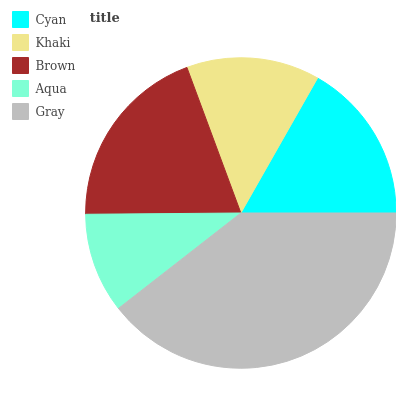Is Aqua the minimum?
Answer yes or no. Yes. Is Gray the maximum?
Answer yes or no. Yes. Is Khaki the minimum?
Answer yes or no. No. Is Khaki the maximum?
Answer yes or no. No. Is Cyan greater than Khaki?
Answer yes or no. Yes. Is Khaki less than Cyan?
Answer yes or no. Yes. Is Khaki greater than Cyan?
Answer yes or no. No. Is Cyan less than Khaki?
Answer yes or no. No. Is Cyan the high median?
Answer yes or no. Yes. Is Cyan the low median?
Answer yes or no. Yes. Is Brown the high median?
Answer yes or no. No. Is Aqua the low median?
Answer yes or no. No. 